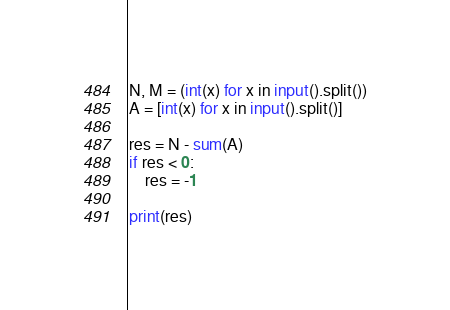<code> <loc_0><loc_0><loc_500><loc_500><_Python_>N, M = (int(x) for x in input().split())
A = [int(x) for x in input().split()]

res = N - sum(A)
if res < 0:
    res = -1

print(res)</code> 